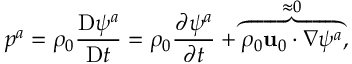<formula> <loc_0><loc_0><loc_500><loc_500>p ^ { a } = \rho _ { 0 } \frac { D \psi ^ { a } } { D t } = \rho _ { 0 } \frac { \partial \psi ^ { a } } { \partial t } + \overbrace { \rho _ { 0 } u _ { 0 } \cdot \nabla \psi ^ { a } } ^ { \approx 0 } ,</formula> 